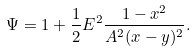Convert formula to latex. <formula><loc_0><loc_0><loc_500><loc_500>\Psi = 1 + \frac { 1 } { 2 } E ^ { 2 } \frac { 1 - x ^ { 2 } } { A ^ { 2 } ( x - y ) ^ { 2 } } .</formula> 